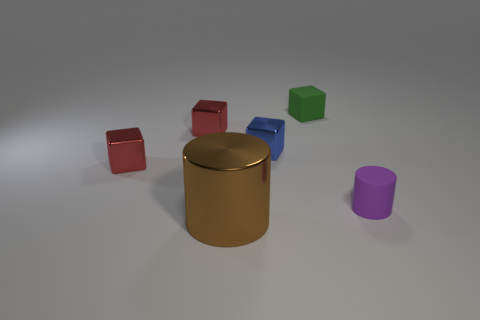Subtract all small metal cubes. How many cubes are left? 1 Subtract all brown cylinders. How many cylinders are left? 1 Subtract 4 blocks. How many blocks are left? 0 Add 1 tiny blue shiny cubes. How many objects exist? 7 Subtract all cylinders. How many objects are left? 4 Subtract all purple cubes. How many blue cylinders are left? 0 Subtract all blue metal things. Subtract all small yellow matte balls. How many objects are left? 5 Add 5 purple objects. How many purple objects are left? 6 Add 1 small matte things. How many small matte things exist? 3 Subtract 0 blue cylinders. How many objects are left? 6 